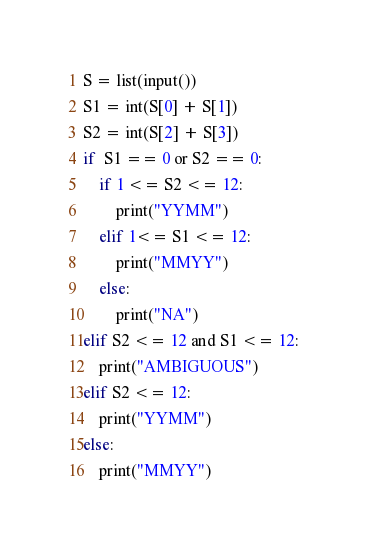Convert code to text. <code><loc_0><loc_0><loc_500><loc_500><_Python_>S = list(input())
S1 = int(S[0] + S[1])
S2 = int(S[2] + S[3])
if  S1 == 0 or S2 == 0:
    if 1 <= S2 <= 12:
        print("YYMM")
    elif 1<= S1 <= 12:
        print("MMYY")
    else:
        print("NA")
elif S2 <= 12 and S1 <= 12:
    print("AMBIGUOUS")
elif S2 <= 12:
    print("YYMM")
else:
    print("MMYY")
</code> 